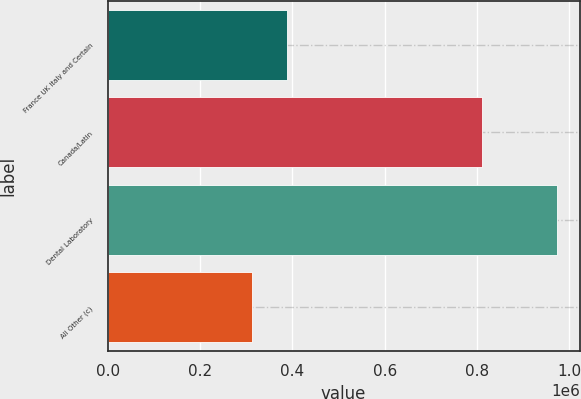Convert chart. <chart><loc_0><loc_0><loc_500><loc_500><bar_chart><fcel>France UK Italy and Certain<fcel>Canada/Latin<fcel>Dental Laboratory<fcel>All Other (c)<nl><fcel>388831<fcel>809924<fcel>973764<fcel>313141<nl></chart> 